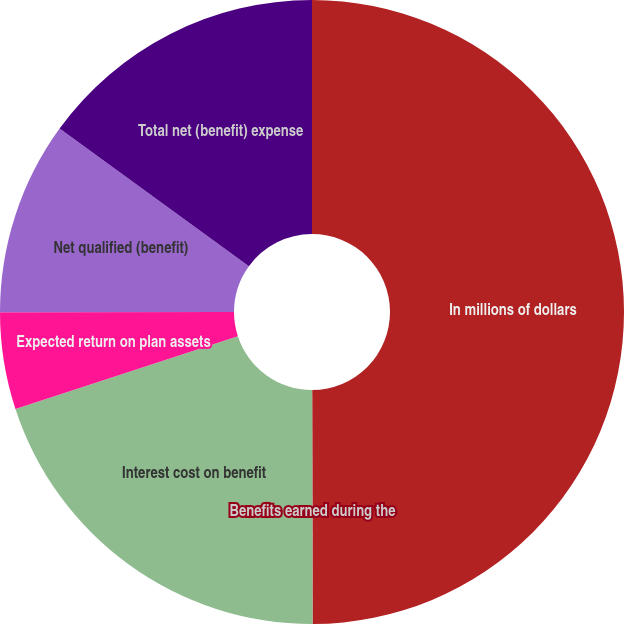Convert chart to OTSL. <chart><loc_0><loc_0><loc_500><loc_500><pie_chart><fcel>In millions of dollars<fcel>Benefits earned during the<fcel>Interest cost on benefit<fcel>Expected return on plan assets<fcel>Net qualified (benefit)<fcel>Total net (benefit) expense<nl><fcel>49.95%<fcel>0.02%<fcel>20.0%<fcel>5.02%<fcel>10.01%<fcel>15.0%<nl></chart> 